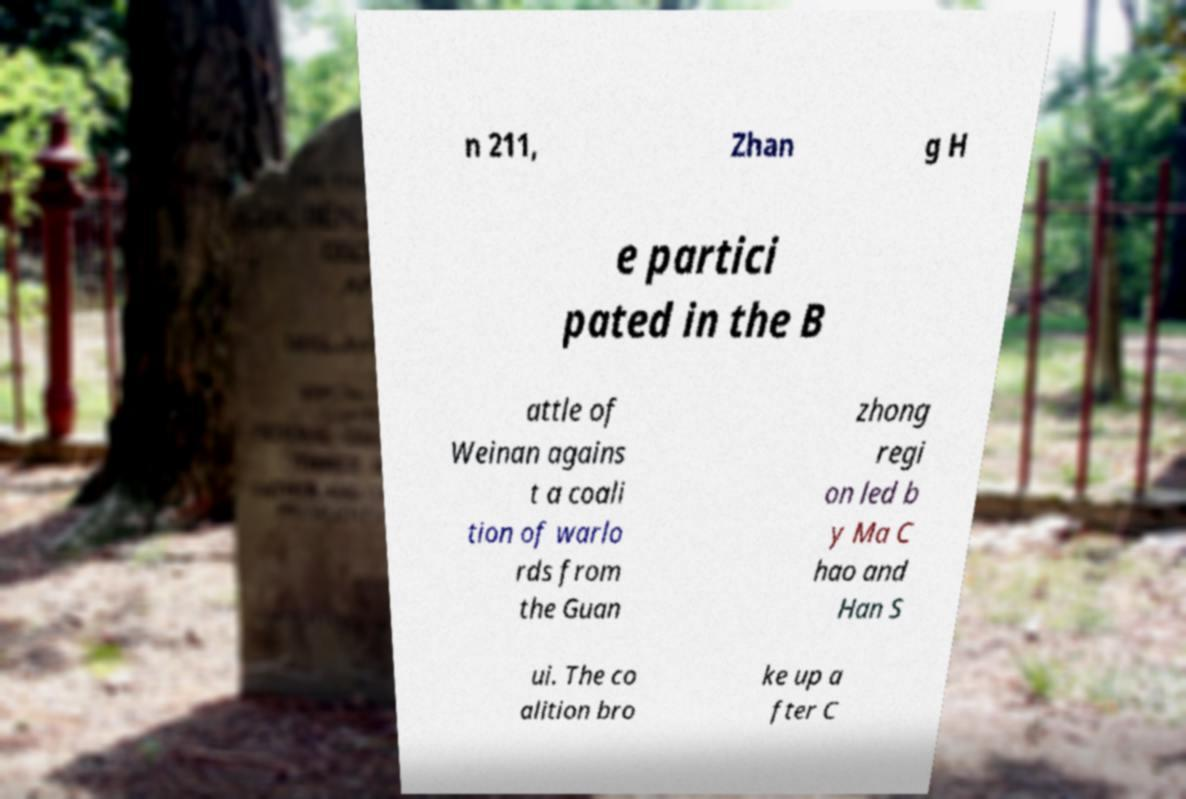Could you assist in decoding the text presented in this image and type it out clearly? n 211, Zhan g H e partici pated in the B attle of Weinan agains t a coali tion of warlo rds from the Guan zhong regi on led b y Ma C hao and Han S ui. The co alition bro ke up a fter C 